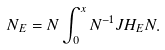<formula> <loc_0><loc_0><loc_500><loc_500>N _ { E } = N \int _ { 0 } ^ { x } N ^ { - 1 } J H _ { E } N .</formula> 